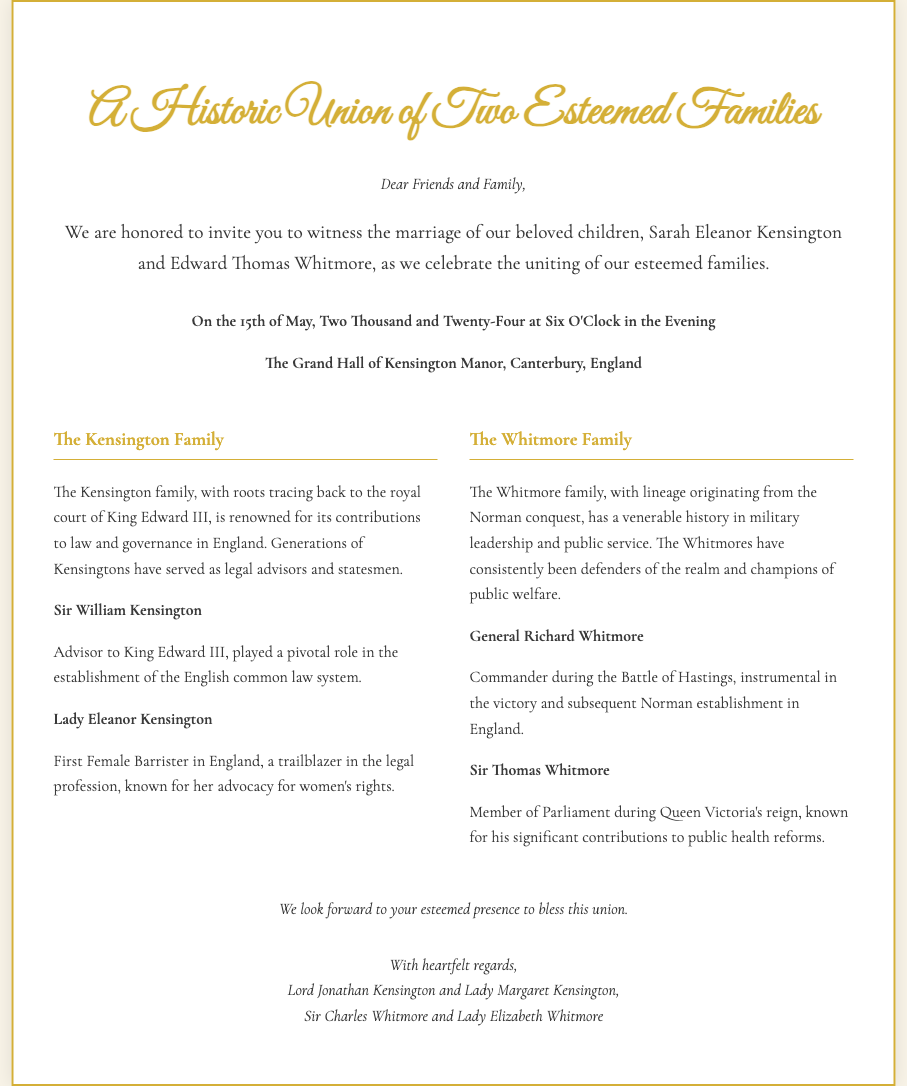What are the names of the couple getting married? The invitation states the couple's names as Sarah Eleanor Kensington and Edward Thomas Whitmore.
Answer: Sarah Eleanor Kensington and Edward Thomas Whitmore What is the date of the wedding? The wedding is scheduled for the 15th of May, Two Thousand and Twenty-Four.
Answer: 15th of May, Two Thousand and Twenty-Four Where is the wedding taking place? The location of the wedding is mentioned as The Grand Hall of Kensington Manor, Canterbury, England.
Answer: The Grand Hall of Kensington Manor, Canterbury, England Who is a notable ancestor from the Kensington family? Sir William Kensington is noted as a significant ancestor of the Kensington family, with a background in advising King Edward III.
Answer: Sir William Kensington What is the significance of Lady Eleanor Kensington? Lady Eleanor Kensington is highlighted as the First Female Barrister in England, recognizing her contributions to women's rights.
Answer: First Female Barrister in England Which family has military leadership origins? The Whitmore family is indicated to have a lineage originating from military leadership, particularly during the Norman conquest.
Answer: The Whitmore family What is the overall theme of this wedding invitation? The overall theme is a historic union celebrated between two esteemed families with significant historical backgrounds.
Answer: Historic union How are the families described in relation to their contributions? The Kensington family is recognized for contributions to law and governance, while the Whitmore family for military leadership and public service.
Answer: Law and governance; military leadership and public service 